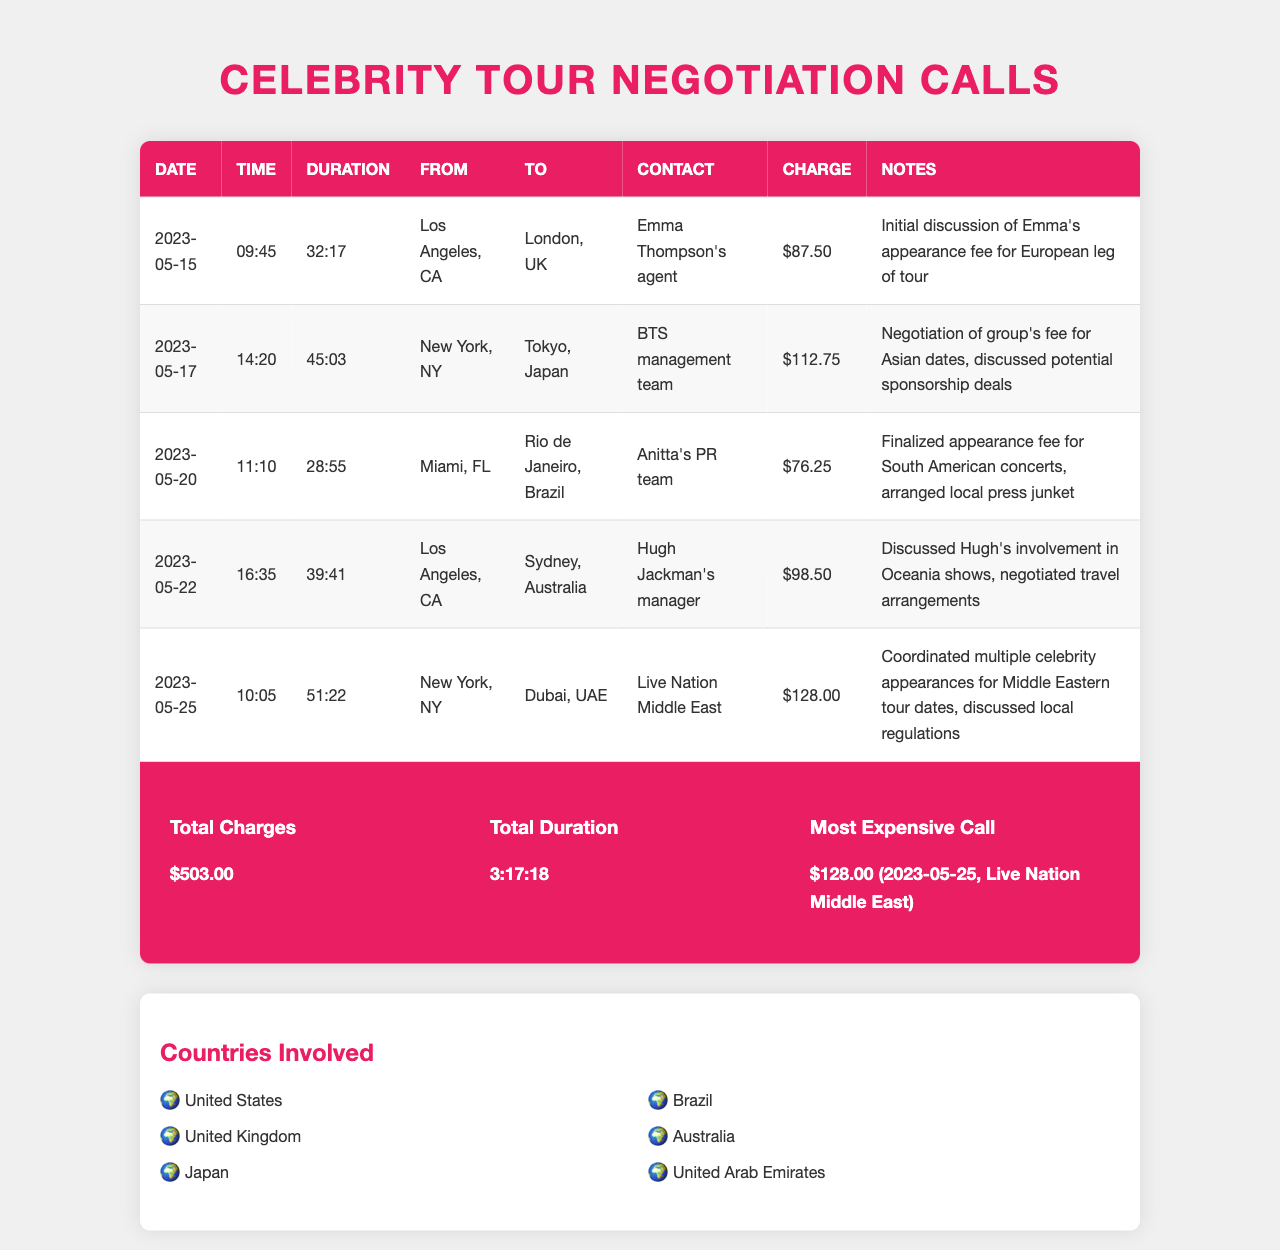what is the total charge incurred? The total charge is listed in the summary section, which sums all individual charges from the calls.
Answer: $503.00 who was the contact for the call on May 20? The contact name is provided in the table for that specific date.
Answer: Anitta's PR team which call had the longest duration? The duration of each call is compared, and the longest one can be identified from the table.
Answer: 51:22 what was the charge for the call on May 25? This charge is specified next to the corresponding call in the records.
Answer: $128.00 how many countries were involved in the negotiations? The number of listed countries in the 'Countries Involved' section will answer this.
Answer: 6 what was the date of the call regarding Hugh Jackman? The date of the call is specified in the table.
Answer: 2023-05-22 which celebrity had their appearance fee finalized in the call from Miami? The table identifies the celebrity discussed for that specific call.
Answer: Anitta what was the total duration of all calls? The total duration is summarized in the summary section of the document.
Answer: 3:17:18 